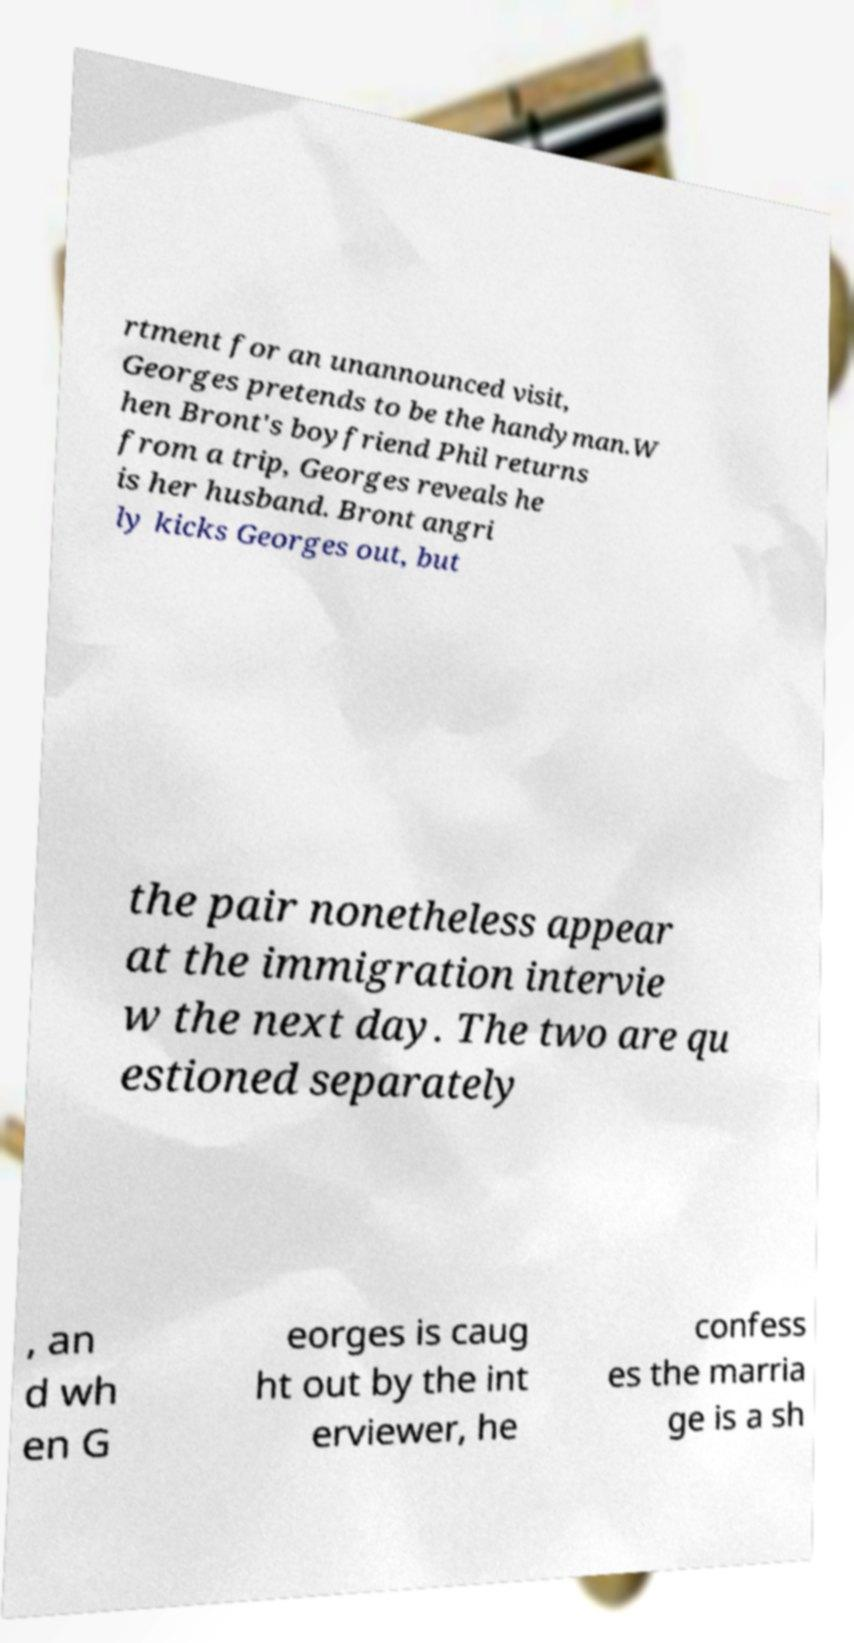There's text embedded in this image that I need extracted. Can you transcribe it verbatim? rtment for an unannounced visit, Georges pretends to be the handyman.W hen Bront's boyfriend Phil returns from a trip, Georges reveals he is her husband. Bront angri ly kicks Georges out, but the pair nonetheless appear at the immigration intervie w the next day. The two are qu estioned separately , an d wh en G eorges is caug ht out by the int erviewer, he confess es the marria ge is a sh 